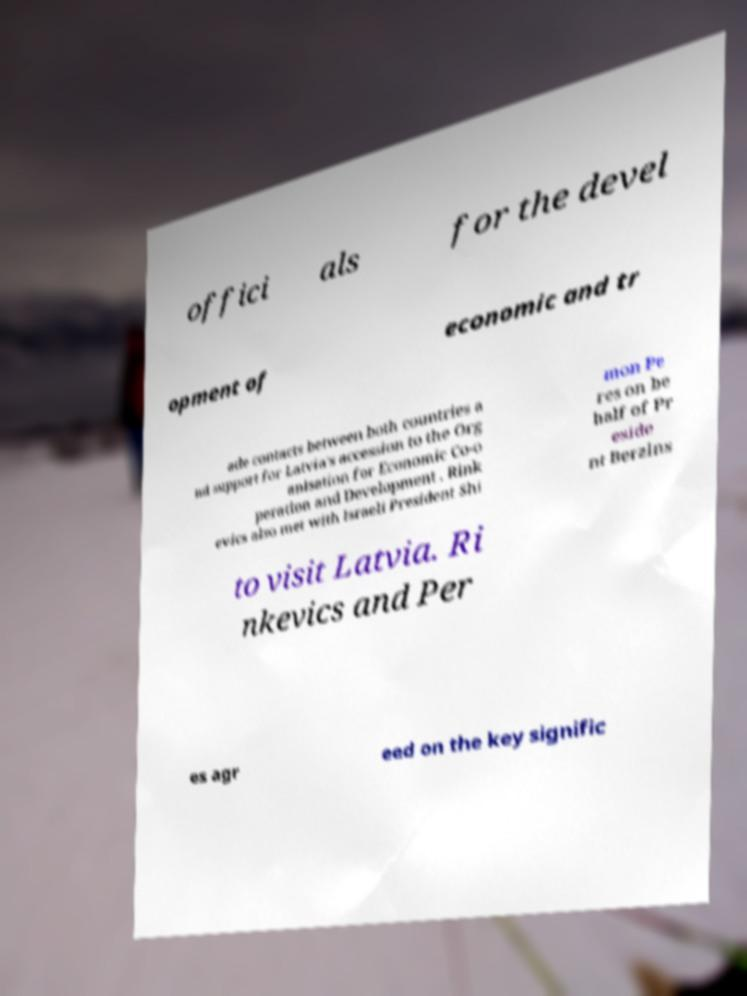Can you read and provide the text displayed in the image?This photo seems to have some interesting text. Can you extract and type it out for me? offici als for the devel opment of economic and tr ade contacts between both countries a nd support for Latvia's accession to the Org anisation for Economic Co-o peration and Development . Rink evics also met with Israeli President Shi mon Pe res on be half of Pr eside nt Berzins to visit Latvia. Ri nkevics and Per es agr eed on the key signific 